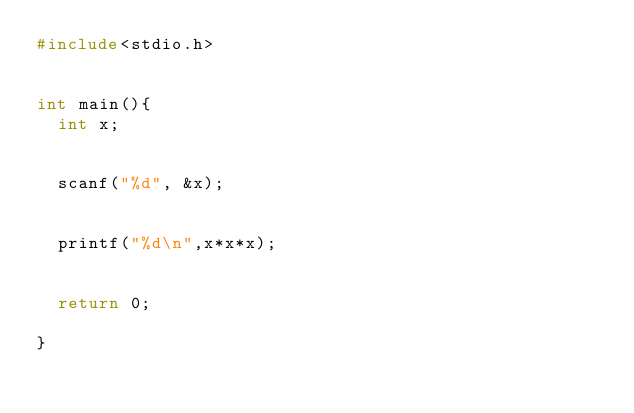Convert code to text. <code><loc_0><loc_0><loc_500><loc_500><_C_>#include<stdio.h>


int main(){
  int x;


  scanf("%d", &x);
  

  printf("%d\n",x*x*x);


  return 0;

}
</code> 